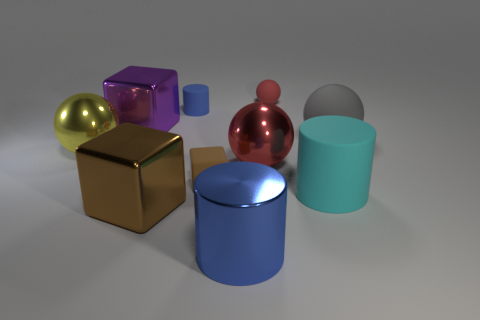Subtract 1 balls. How many balls are left? 3 Subtract all yellow cylinders. Subtract all purple balls. How many cylinders are left? 3 Subtract all cubes. How many objects are left? 7 Add 4 rubber spheres. How many rubber spheres are left? 6 Add 4 tiny green spheres. How many tiny green spheres exist? 4 Subtract 0 blue blocks. How many objects are left? 10 Subtract all tiny blue objects. Subtract all purple shiny cubes. How many objects are left? 8 